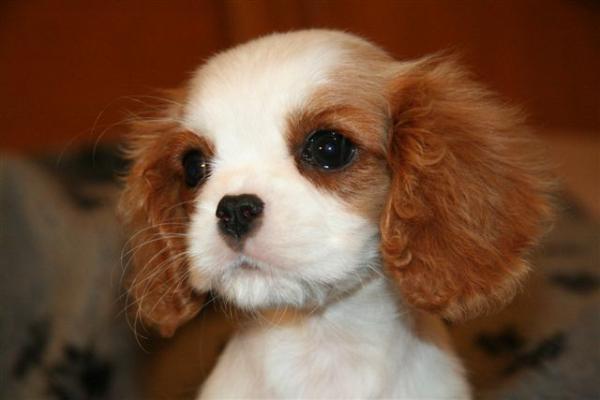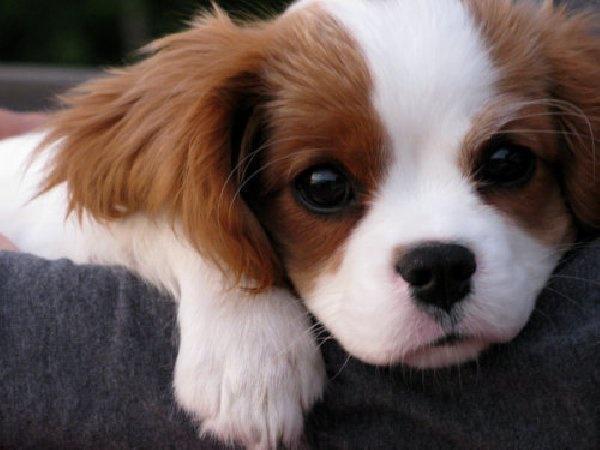The first image is the image on the left, the second image is the image on the right. Evaluate the accuracy of this statement regarding the images: "the right image has a dog on a brwon floor with a tan pillar behind them". Is it true? Answer yes or no. No. The first image is the image on the left, the second image is the image on the right. Assess this claim about the two images: "In one image there is a lone Cavalier King Charles Spaniel laying down looking at the camera in the center of the image.". Correct or not? Answer yes or no. Yes. 